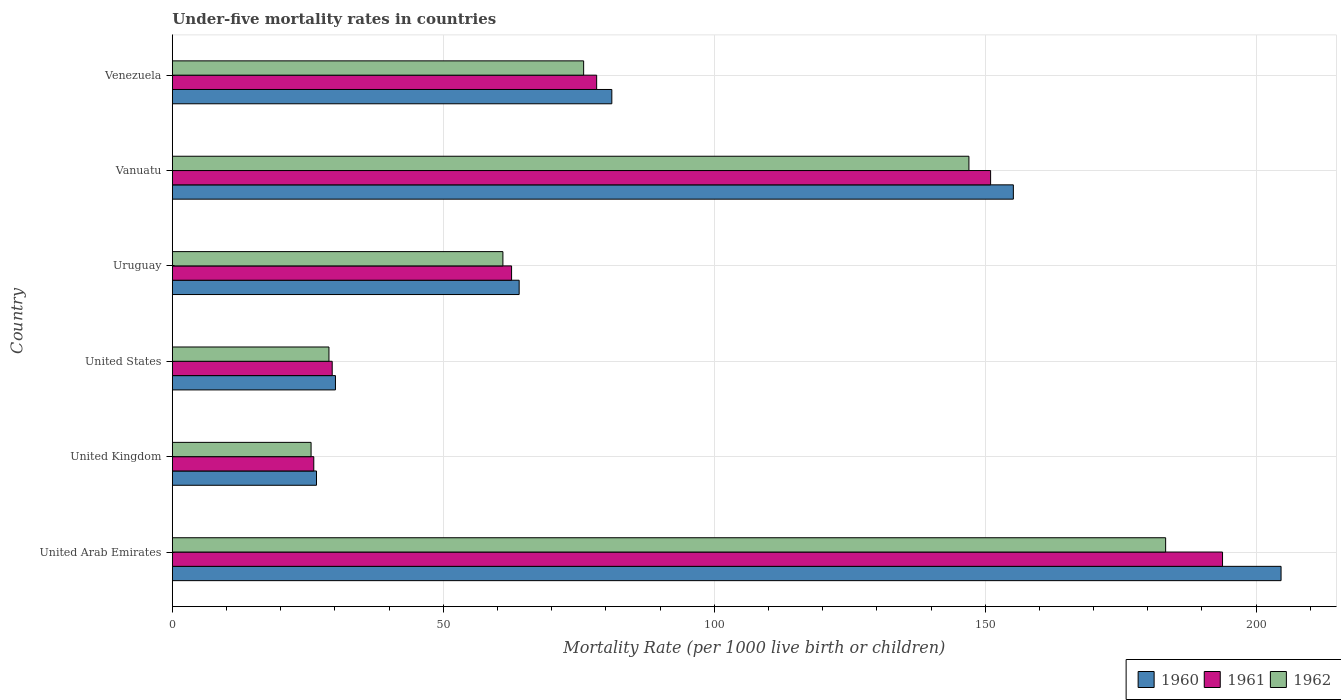How many different coloured bars are there?
Your answer should be very brief. 3. How many groups of bars are there?
Your answer should be very brief. 6. Are the number of bars per tick equal to the number of legend labels?
Ensure brevity in your answer.  Yes. In how many cases, is the number of bars for a given country not equal to the number of legend labels?
Give a very brief answer. 0. What is the under-five mortality rate in 1962 in Vanuatu?
Your answer should be compact. 147. Across all countries, what is the maximum under-five mortality rate in 1960?
Offer a terse response. 204.6. Across all countries, what is the minimum under-five mortality rate in 1960?
Make the answer very short. 26.6. In which country was the under-five mortality rate in 1960 maximum?
Ensure brevity in your answer.  United Arab Emirates. What is the total under-five mortality rate in 1960 in the graph?
Ensure brevity in your answer.  561.6. What is the difference between the under-five mortality rate in 1962 in United States and that in Uruguay?
Provide a succinct answer. -32.1. What is the difference between the under-five mortality rate in 1961 in Uruguay and the under-five mortality rate in 1962 in Vanuatu?
Your answer should be very brief. -84.4. What is the average under-five mortality rate in 1962 per country?
Offer a terse response. 86.95. What is the difference between the under-five mortality rate in 1961 and under-five mortality rate in 1962 in Venezuela?
Your response must be concise. 2.4. In how many countries, is the under-five mortality rate in 1961 greater than 70 ?
Your answer should be compact. 3. What is the ratio of the under-five mortality rate in 1961 in United Kingdom to that in United States?
Make the answer very short. 0.88. What is the difference between the highest and the second highest under-five mortality rate in 1961?
Keep it short and to the point. 42.8. What is the difference between the highest and the lowest under-five mortality rate in 1962?
Provide a succinct answer. 157.7. What does the 1st bar from the top in Vanuatu represents?
Your response must be concise. 1962. What does the 2nd bar from the bottom in United Kingdom represents?
Keep it short and to the point. 1961. How many bars are there?
Your answer should be compact. 18. Does the graph contain grids?
Offer a terse response. Yes. How are the legend labels stacked?
Your response must be concise. Horizontal. What is the title of the graph?
Make the answer very short. Under-five mortality rates in countries. Does "2004" appear as one of the legend labels in the graph?
Provide a succinct answer. No. What is the label or title of the X-axis?
Your answer should be compact. Mortality Rate (per 1000 live birth or children). What is the label or title of the Y-axis?
Make the answer very short. Country. What is the Mortality Rate (per 1000 live birth or children) in 1960 in United Arab Emirates?
Your response must be concise. 204.6. What is the Mortality Rate (per 1000 live birth or children) in 1961 in United Arab Emirates?
Make the answer very short. 193.8. What is the Mortality Rate (per 1000 live birth or children) in 1962 in United Arab Emirates?
Make the answer very short. 183.3. What is the Mortality Rate (per 1000 live birth or children) of 1960 in United Kingdom?
Your answer should be compact. 26.6. What is the Mortality Rate (per 1000 live birth or children) in 1961 in United Kingdom?
Ensure brevity in your answer.  26.1. What is the Mortality Rate (per 1000 live birth or children) in 1962 in United Kingdom?
Provide a succinct answer. 25.6. What is the Mortality Rate (per 1000 live birth or children) in 1960 in United States?
Ensure brevity in your answer.  30.1. What is the Mortality Rate (per 1000 live birth or children) in 1961 in United States?
Give a very brief answer. 29.5. What is the Mortality Rate (per 1000 live birth or children) of 1962 in United States?
Make the answer very short. 28.9. What is the Mortality Rate (per 1000 live birth or children) of 1960 in Uruguay?
Provide a short and direct response. 64. What is the Mortality Rate (per 1000 live birth or children) in 1961 in Uruguay?
Keep it short and to the point. 62.6. What is the Mortality Rate (per 1000 live birth or children) in 1962 in Uruguay?
Make the answer very short. 61. What is the Mortality Rate (per 1000 live birth or children) of 1960 in Vanuatu?
Offer a terse response. 155.2. What is the Mortality Rate (per 1000 live birth or children) of 1961 in Vanuatu?
Give a very brief answer. 151. What is the Mortality Rate (per 1000 live birth or children) in 1962 in Vanuatu?
Your answer should be very brief. 147. What is the Mortality Rate (per 1000 live birth or children) of 1960 in Venezuela?
Offer a terse response. 81.1. What is the Mortality Rate (per 1000 live birth or children) of 1961 in Venezuela?
Ensure brevity in your answer.  78.3. What is the Mortality Rate (per 1000 live birth or children) in 1962 in Venezuela?
Ensure brevity in your answer.  75.9. Across all countries, what is the maximum Mortality Rate (per 1000 live birth or children) in 1960?
Your answer should be very brief. 204.6. Across all countries, what is the maximum Mortality Rate (per 1000 live birth or children) in 1961?
Ensure brevity in your answer.  193.8. Across all countries, what is the maximum Mortality Rate (per 1000 live birth or children) of 1962?
Offer a terse response. 183.3. Across all countries, what is the minimum Mortality Rate (per 1000 live birth or children) in 1960?
Make the answer very short. 26.6. Across all countries, what is the minimum Mortality Rate (per 1000 live birth or children) in 1961?
Offer a very short reply. 26.1. Across all countries, what is the minimum Mortality Rate (per 1000 live birth or children) of 1962?
Provide a succinct answer. 25.6. What is the total Mortality Rate (per 1000 live birth or children) of 1960 in the graph?
Offer a terse response. 561.6. What is the total Mortality Rate (per 1000 live birth or children) in 1961 in the graph?
Your answer should be compact. 541.3. What is the total Mortality Rate (per 1000 live birth or children) of 1962 in the graph?
Offer a terse response. 521.7. What is the difference between the Mortality Rate (per 1000 live birth or children) of 1960 in United Arab Emirates and that in United Kingdom?
Offer a terse response. 178. What is the difference between the Mortality Rate (per 1000 live birth or children) of 1961 in United Arab Emirates and that in United Kingdom?
Give a very brief answer. 167.7. What is the difference between the Mortality Rate (per 1000 live birth or children) of 1962 in United Arab Emirates and that in United Kingdom?
Provide a short and direct response. 157.7. What is the difference between the Mortality Rate (per 1000 live birth or children) of 1960 in United Arab Emirates and that in United States?
Give a very brief answer. 174.5. What is the difference between the Mortality Rate (per 1000 live birth or children) of 1961 in United Arab Emirates and that in United States?
Ensure brevity in your answer.  164.3. What is the difference between the Mortality Rate (per 1000 live birth or children) in 1962 in United Arab Emirates and that in United States?
Offer a terse response. 154.4. What is the difference between the Mortality Rate (per 1000 live birth or children) in 1960 in United Arab Emirates and that in Uruguay?
Provide a succinct answer. 140.6. What is the difference between the Mortality Rate (per 1000 live birth or children) of 1961 in United Arab Emirates and that in Uruguay?
Your answer should be compact. 131.2. What is the difference between the Mortality Rate (per 1000 live birth or children) in 1962 in United Arab Emirates and that in Uruguay?
Your answer should be very brief. 122.3. What is the difference between the Mortality Rate (per 1000 live birth or children) of 1960 in United Arab Emirates and that in Vanuatu?
Offer a terse response. 49.4. What is the difference between the Mortality Rate (per 1000 live birth or children) in 1961 in United Arab Emirates and that in Vanuatu?
Provide a short and direct response. 42.8. What is the difference between the Mortality Rate (per 1000 live birth or children) of 1962 in United Arab Emirates and that in Vanuatu?
Offer a very short reply. 36.3. What is the difference between the Mortality Rate (per 1000 live birth or children) of 1960 in United Arab Emirates and that in Venezuela?
Make the answer very short. 123.5. What is the difference between the Mortality Rate (per 1000 live birth or children) in 1961 in United Arab Emirates and that in Venezuela?
Your answer should be compact. 115.5. What is the difference between the Mortality Rate (per 1000 live birth or children) of 1962 in United Arab Emirates and that in Venezuela?
Provide a succinct answer. 107.4. What is the difference between the Mortality Rate (per 1000 live birth or children) of 1960 in United Kingdom and that in United States?
Your answer should be very brief. -3.5. What is the difference between the Mortality Rate (per 1000 live birth or children) of 1962 in United Kingdom and that in United States?
Offer a terse response. -3.3. What is the difference between the Mortality Rate (per 1000 live birth or children) of 1960 in United Kingdom and that in Uruguay?
Provide a succinct answer. -37.4. What is the difference between the Mortality Rate (per 1000 live birth or children) in 1961 in United Kingdom and that in Uruguay?
Make the answer very short. -36.5. What is the difference between the Mortality Rate (per 1000 live birth or children) in 1962 in United Kingdom and that in Uruguay?
Your answer should be very brief. -35.4. What is the difference between the Mortality Rate (per 1000 live birth or children) of 1960 in United Kingdom and that in Vanuatu?
Keep it short and to the point. -128.6. What is the difference between the Mortality Rate (per 1000 live birth or children) of 1961 in United Kingdom and that in Vanuatu?
Your answer should be very brief. -124.9. What is the difference between the Mortality Rate (per 1000 live birth or children) in 1962 in United Kingdom and that in Vanuatu?
Your answer should be compact. -121.4. What is the difference between the Mortality Rate (per 1000 live birth or children) of 1960 in United Kingdom and that in Venezuela?
Offer a very short reply. -54.5. What is the difference between the Mortality Rate (per 1000 live birth or children) of 1961 in United Kingdom and that in Venezuela?
Ensure brevity in your answer.  -52.2. What is the difference between the Mortality Rate (per 1000 live birth or children) of 1962 in United Kingdom and that in Venezuela?
Make the answer very short. -50.3. What is the difference between the Mortality Rate (per 1000 live birth or children) of 1960 in United States and that in Uruguay?
Ensure brevity in your answer.  -33.9. What is the difference between the Mortality Rate (per 1000 live birth or children) of 1961 in United States and that in Uruguay?
Make the answer very short. -33.1. What is the difference between the Mortality Rate (per 1000 live birth or children) of 1962 in United States and that in Uruguay?
Provide a succinct answer. -32.1. What is the difference between the Mortality Rate (per 1000 live birth or children) of 1960 in United States and that in Vanuatu?
Offer a very short reply. -125.1. What is the difference between the Mortality Rate (per 1000 live birth or children) of 1961 in United States and that in Vanuatu?
Offer a very short reply. -121.5. What is the difference between the Mortality Rate (per 1000 live birth or children) of 1962 in United States and that in Vanuatu?
Your answer should be compact. -118.1. What is the difference between the Mortality Rate (per 1000 live birth or children) in 1960 in United States and that in Venezuela?
Offer a terse response. -51. What is the difference between the Mortality Rate (per 1000 live birth or children) of 1961 in United States and that in Venezuela?
Give a very brief answer. -48.8. What is the difference between the Mortality Rate (per 1000 live birth or children) of 1962 in United States and that in Venezuela?
Provide a succinct answer. -47. What is the difference between the Mortality Rate (per 1000 live birth or children) in 1960 in Uruguay and that in Vanuatu?
Make the answer very short. -91.2. What is the difference between the Mortality Rate (per 1000 live birth or children) in 1961 in Uruguay and that in Vanuatu?
Make the answer very short. -88.4. What is the difference between the Mortality Rate (per 1000 live birth or children) of 1962 in Uruguay and that in Vanuatu?
Ensure brevity in your answer.  -86. What is the difference between the Mortality Rate (per 1000 live birth or children) in 1960 in Uruguay and that in Venezuela?
Your response must be concise. -17.1. What is the difference between the Mortality Rate (per 1000 live birth or children) of 1961 in Uruguay and that in Venezuela?
Your answer should be very brief. -15.7. What is the difference between the Mortality Rate (per 1000 live birth or children) in 1962 in Uruguay and that in Venezuela?
Provide a succinct answer. -14.9. What is the difference between the Mortality Rate (per 1000 live birth or children) in 1960 in Vanuatu and that in Venezuela?
Your answer should be compact. 74.1. What is the difference between the Mortality Rate (per 1000 live birth or children) of 1961 in Vanuatu and that in Venezuela?
Keep it short and to the point. 72.7. What is the difference between the Mortality Rate (per 1000 live birth or children) of 1962 in Vanuatu and that in Venezuela?
Provide a succinct answer. 71.1. What is the difference between the Mortality Rate (per 1000 live birth or children) of 1960 in United Arab Emirates and the Mortality Rate (per 1000 live birth or children) of 1961 in United Kingdom?
Your response must be concise. 178.5. What is the difference between the Mortality Rate (per 1000 live birth or children) in 1960 in United Arab Emirates and the Mortality Rate (per 1000 live birth or children) in 1962 in United Kingdom?
Provide a short and direct response. 179. What is the difference between the Mortality Rate (per 1000 live birth or children) in 1961 in United Arab Emirates and the Mortality Rate (per 1000 live birth or children) in 1962 in United Kingdom?
Provide a short and direct response. 168.2. What is the difference between the Mortality Rate (per 1000 live birth or children) in 1960 in United Arab Emirates and the Mortality Rate (per 1000 live birth or children) in 1961 in United States?
Offer a terse response. 175.1. What is the difference between the Mortality Rate (per 1000 live birth or children) of 1960 in United Arab Emirates and the Mortality Rate (per 1000 live birth or children) of 1962 in United States?
Offer a terse response. 175.7. What is the difference between the Mortality Rate (per 1000 live birth or children) in 1961 in United Arab Emirates and the Mortality Rate (per 1000 live birth or children) in 1962 in United States?
Offer a very short reply. 164.9. What is the difference between the Mortality Rate (per 1000 live birth or children) in 1960 in United Arab Emirates and the Mortality Rate (per 1000 live birth or children) in 1961 in Uruguay?
Offer a terse response. 142. What is the difference between the Mortality Rate (per 1000 live birth or children) in 1960 in United Arab Emirates and the Mortality Rate (per 1000 live birth or children) in 1962 in Uruguay?
Offer a very short reply. 143.6. What is the difference between the Mortality Rate (per 1000 live birth or children) of 1961 in United Arab Emirates and the Mortality Rate (per 1000 live birth or children) of 1962 in Uruguay?
Give a very brief answer. 132.8. What is the difference between the Mortality Rate (per 1000 live birth or children) of 1960 in United Arab Emirates and the Mortality Rate (per 1000 live birth or children) of 1961 in Vanuatu?
Your response must be concise. 53.6. What is the difference between the Mortality Rate (per 1000 live birth or children) in 1960 in United Arab Emirates and the Mortality Rate (per 1000 live birth or children) in 1962 in Vanuatu?
Offer a terse response. 57.6. What is the difference between the Mortality Rate (per 1000 live birth or children) in 1961 in United Arab Emirates and the Mortality Rate (per 1000 live birth or children) in 1962 in Vanuatu?
Your answer should be compact. 46.8. What is the difference between the Mortality Rate (per 1000 live birth or children) of 1960 in United Arab Emirates and the Mortality Rate (per 1000 live birth or children) of 1961 in Venezuela?
Give a very brief answer. 126.3. What is the difference between the Mortality Rate (per 1000 live birth or children) in 1960 in United Arab Emirates and the Mortality Rate (per 1000 live birth or children) in 1962 in Venezuela?
Offer a terse response. 128.7. What is the difference between the Mortality Rate (per 1000 live birth or children) of 1961 in United Arab Emirates and the Mortality Rate (per 1000 live birth or children) of 1962 in Venezuela?
Ensure brevity in your answer.  117.9. What is the difference between the Mortality Rate (per 1000 live birth or children) of 1960 in United Kingdom and the Mortality Rate (per 1000 live birth or children) of 1961 in United States?
Your response must be concise. -2.9. What is the difference between the Mortality Rate (per 1000 live birth or children) in 1960 in United Kingdom and the Mortality Rate (per 1000 live birth or children) in 1961 in Uruguay?
Provide a succinct answer. -36. What is the difference between the Mortality Rate (per 1000 live birth or children) in 1960 in United Kingdom and the Mortality Rate (per 1000 live birth or children) in 1962 in Uruguay?
Make the answer very short. -34.4. What is the difference between the Mortality Rate (per 1000 live birth or children) of 1961 in United Kingdom and the Mortality Rate (per 1000 live birth or children) of 1962 in Uruguay?
Keep it short and to the point. -34.9. What is the difference between the Mortality Rate (per 1000 live birth or children) of 1960 in United Kingdom and the Mortality Rate (per 1000 live birth or children) of 1961 in Vanuatu?
Give a very brief answer. -124.4. What is the difference between the Mortality Rate (per 1000 live birth or children) of 1960 in United Kingdom and the Mortality Rate (per 1000 live birth or children) of 1962 in Vanuatu?
Your answer should be compact. -120.4. What is the difference between the Mortality Rate (per 1000 live birth or children) in 1961 in United Kingdom and the Mortality Rate (per 1000 live birth or children) in 1962 in Vanuatu?
Make the answer very short. -120.9. What is the difference between the Mortality Rate (per 1000 live birth or children) in 1960 in United Kingdom and the Mortality Rate (per 1000 live birth or children) in 1961 in Venezuela?
Your response must be concise. -51.7. What is the difference between the Mortality Rate (per 1000 live birth or children) of 1960 in United Kingdom and the Mortality Rate (per 1000 live birth or children) of 1962 in Venezuela?
Keep it short and to the point. -49.3. What is the difference between the Mortality Rate (per 1000 live birth or children) in 1961 in United Kingdom and the Mortality Rate (per 1000 live birth or children) in 1962 in Venezuela?
Ensure brevity in your answer.  -49.8. What is the difference between the Mortality Rate (per 1000 live birth or children) in 1960 in United States and the Mortality Rate (per 1000 live birth or children) in 1961 in Uruguay?
Your response must be concise. -32.5. What is the difference between the Mortality Rate (per 1000 live birth or children) in 1960 in United States and the Mortality Rate (per 1000 live birth or children) in 1962 in Uruguay?
Ensure brevity in your answer.  -30.9. What is the difference between the Mortality Rate (per 1000 live birth or children) in 1961 in United States and the Mortality Rate (per 1000 live birth or children) in 1962 in Uruguay?
Your response must be concise. -31.5. What is the difference between the Mortality Rate (per 1000 live birth or children) of 1960 in United States and the Mortality Rate (per 1000 live birth or children) of 1961 in Vanuatu?
Offer a terse response. -120.9. What is the difference between the Mortality Rate (per 1000 live birth or children) in 1960 in United States and the Mortality Rate (per 1000 live birth or children) in 1962 in Vanuatu?
Make the answer very short. -116.9. What is the difference between the Mortality Rate (per 1000 live birth or children) of 1961 in United States and the Mortality Rate (per 1000 live birth or children) of 1962 in Vanuatu?
Provide a succinct answer. -117.5. What is the difference between the Mortality Rate (per 1000 live birth or children) of 1960 in United States and the Mortality Rate (per 1000 live birth or children) of 1961 in Venezuela?
Give a very brief answer. -48.2. What is the difference between the Mortality Rate (per 1000 live birth or children) of 1960 in United States and the Mortality Rate (per 1000 live birth or children) of 1962 in Venezuela?
Ensure brevity in your answer.  -45.8. What is the difference between the Mortality Rate (per 1000 live birth or children) of 1961 in United States and the Mortality Rate (per 1000 live birth or children) of 1962 in Venezuela?
Provide a short and direct response. -46.4. What is the difference between the Mortality Rate (per 1000 live birth or children) in 1960 in Uruguay and the Mortality Rate (per 1000 live birth or children) in 1961 in Vanuatu?
Provide a short and direct response. -87. What is the difference between the Mortality Rate (per 1000 live birth or children) in 1960 in Uruguay and the Mortality Rate (per 1000 live birth or children) in 1962 in Vanuatu?
Offer a very short reply. -83. What is the difference between the Mortality Rate (per 1000 live birth or children) of 1961 in Uruguay and the Mortality Rate (per 1000 live birth or children) of 1962 in Vanuatu?
Offer a terse response. -84.4. What is the difference between the Mortality Rate (per 1000 live birth or children) in 1960 in Uruguay and the Mortality Rate (per 1000 live birth or children) in 1961 in Venezuela?
Your answer should be compact. -14.3. What is the difference between the Mortality Rate (per 1000 live birth or children) in 1961 in Uruguay and the Mortality Rate (per 1000 live birth or children) in 1962 in Venezuela?
Your response must be concise. -13.3. What is the difference between the Mortality Rate (per 1000 live birth or children) of 1960 in Vanuatu and the Mortality Rate (per 1000 live birth or children) of 1961 in Venezuela?
Your answer should be very brief. 76.9. What is the difference between the Mortality Rate (per 1000 live birth or children) of 1960 in Vanuatu and the Mortality Rate (per 1000 live birth or children) of 1962 in Venezuela?
Your answer should be compact. 79.3. What is the difference between the Mortality Rate (per 1000 live birth or children) of 1961 in Vanuatu and the Mortality Rate (per 1000 live birth or children) of 1962 in Venezuela?
Provide a succinct answer. 75.1. What is the average Mortality Rate (per 1000 live birth or children) in 1960 per country?
Offer a very short reply. 93.6. What is the average Mortality Rate (per 1000 live birth or children) of 1961 per country?
Provide a short and direct response. 90.22. What is the average Mortality Rate (per 1000 live birth or children) of 1962 per country?
Make the answer very short. 86.95. What is the difference between the Mortality Rate (per 1000 live birth or children) of 1960 and Mortality Rate (per 1000 live birth or children) of 1961 in United Arab Emirates?
Make the answer very short. 10.8. What is the difference between the Mortality Rate (per 1000 live birth or children) of 1960 and Mortality Rate (per 1000 live birth or children) of 1962 in United Arab Emirates?
Give a very brief answer. 21.3. What is the difference between the Mortality Rate (per 1000 live birth or children) in 1961 and Mortality Rate (per 1000 live birth or children) in 1962 in United Arab Emirates?
Provide a succinct answer. 10.5. What is the difference between the Mortality Rate (per 1000 live birth or children) of 1960 and Mortality Rate (per 1000 live birth or children) of 1961 in United Kingdom?
Provide a short and direct response. 0.5. What is the difference between the Mortality Rate (per 1000 live birth or children) of 1961 and Mortality Rate (per 1000 live birth or children) of 1962 in United Kingdom?
Keep it short and to the point. 0.5. What is the difference between the Mortality Rate (per 1000 live birth or children) of 1960 and Mortality Rate (per 1000 live birth or children) of 1962 in United States?
Ensure brevity in your answer.  1.2. What is the difference between the Mortality Rate (per 1000 live birth or children) of 1960 and Mortality Rate (per 1000 live birth or children) of 1962 in Vanuatu?
Offer a terse response. 8.2. What is the difference between the Mortality Rate (per 1000 live birth or children) in 1961 and Mortality Rate (per 1000 live birth or children) in 1962 in Vanuatu?
Your answer should be very brief. 4. What is the difference between the Mortality Rate (per 1000 live birth or children) of 1960 and Mortality Rate (per 1000 live birth or children) of 1962 in Venezuela?
Give a very brief answer. 5.2. What is the ratio of the Mortality Rate (per 1000 live birth or children) of 1960 in United Arab Emirates to that in United Kingdom?
Make the answer very short. 7.69. What is the ratio of the Mortality Rate (per 1000 live birth or children) in 1961 in United Arab Emirates to that in United Kingdom?
Your answer should be compact. 7.43. What is the ratio of the Mortality Rate (per 1000 live birth or children) in 1962 in United Arab Emirates to that in United Kingdom?
Provide a short and direct response. 7.16. What is the ratio of the Mortality Rate (per 1000 live birth or children) of 1960 in United Arab Emirates to that in United States?
Your answer should be very brief. 6.8. What is the ratio of the Mortality Rate (per 1000 live birth or children) of 1961 in United Arab Emirates to that in United States?
Ensure brevity in your answer.  6.57. What is the ratio of the Mortality Rate (per 1000 live birth or children) of 1962 in United Arab Emirates to that in United States?
Make the answer very short. 6.34. What is the ratio of the Mortality Rate (per 1000 live birth or children) of 1960 in United Arab Emirates to that in Uruguay?
Give a very brief answer. 3.2. What is the ratio of the Mortality Rate (per 1000 live birth or children) of 1961 in United Arab Emirates to that in Uruguay?
Your response must be concise. 3.1. What is the ratio of the Mortality Rate (per 1000 live birth or children) in 1962 in United Arab Emirates to that in Uruguay?
Give a very brief answer. 3. What is the ratio of the Mortality Rate (per 1000 live birth or children) in 1960 in United Arab Emirates to that in Vanuatu?
Your answer should be compact. 1.32. What is the ratio of the Mortality Rate (per 1000 live birth or children) in 1961 in United Arab Emirates to that in Vanuatu?
Give a very brief answer. 1.28. What is the ratio of the Mortality Rate (per 1000 live birth or children) in 1962 in United Arab Emirates to that in Vanuatu?
Your answer should be very brief. 1.25. What is the ratio of the Mortality Rate (per 1000 live birth or children) in 1960 in United Arab Emirates to that in Venezuela?
Your response must be concise. 2.52. What is the ratio of the Mortality Rate (per 1000 live birth or children) of 1961 in United Arab Emirates to that in Venezuela?
Offer a very short reply. 2.48. What is the ratio of the Mortality Rate (per 1000 live birth or children) in 1962 in United Arab Emirates to that in Venezuela?
Offer a terse response. 2.42. What is the ratio of the Mortality Rate (per 1000 live birth or children) of 1960 in United Kingdom to that in United States?
Your response must be concise. 0.88. What is the ratio of the Mortality Rate (per 1000 live birth or children) of 1961 in United Kingdom to that in United States?
Keep it short and to the point. 0.88. What is the ratio of the Mortality Rate (per 1000 live birth or children) in 1962 in United Kingdom to that in United States?
Ensure brevity in your answer.  0.89. What is the ratio of the Mortality Rate (per 1000 live birth or children) of 1960 in United Kingdom to that in Uruguay?
Make the answer very short. 0.42. What is the ratio of the Mortality Rate (per 1000 live birth or children) in 1961 in United Kingdom to that in Uruguay?
Ensure brevity in your answer.  0.42. What is the ratio of the Mortality Rate (per 1000 live birth or children) of 1962 in United Kingdom to that in Uruguay?
Offer a very short reply. 0.42. What is the ratio of the Mortality Rate (per 1000 live birth or children) of 1960 in United Kingdom to that in Vanuatu?
Offer a very short reply. 0.17. What is the ratio of the Mortality Rate (per 1000 live birth or children) of 1961 in United Kingdom to that in Vanuatu?
Make the answer very short. 0.17. What is the ratio of the Mortality Rate (per 1000 live birth or children) in 1962 in United Kingdom to that in Vanuatu?
Provide a succinct answer. 0.17. What is the ratio of the Mortality Rate (per 1000 live birth or children) of 1960 in United Kingdom to that in Venezuela?
Offer a very short reply. 0.33. What is the ratio of the Mortality Rate (per 1000 live birth or children) of 1961 in United Kingdom to that in Venezuela?
Give a very brief answer. 0.33. What is the ratio of the Mortality Rate (per 1000 live birth or children) of 1962 in United Kingdom to that in Venezuela?
Your response must be concise. 0.34. What is the ratio of the Mortality Rate (per 1000 live birth or children) in 1960 in United States to that in Uruguay?
Your answer should be very brief. 0.47. What is the ratio of the Mortality Rate (per 1000 live birth or children) of 1961 in United States to that in Uruguay?
Keep it short and to the point. 0.47. What is the ratio of the Mortality Rate (per 1000 live birth or children) of 1962 in United States to that in Uruguay?
Offer a very short reply. 0.47. What is the ratio of the Mortality Rate (per 1000 live birth or children) of 1960 in United States to that in Vanuatu?
Give a very brief answer. 0.19. What is the ratio of the Mortality Rate (per 1000 live birth or children) in 1961 in United States to that in Vanuatu?
Give a very brief answer. 0.2. What is the ratio of the Mortality Rate (per 1000 live birth or children) of 1962 in United States to that in Vanuatu?
Your response must be concise. 0.2. What is the ratio of the Mortality Rate (per 1000 live birth or children) in 1960 in United States to that in Venezuela?
Ensure brevity in your answer.  0.37. What is the ratio of the Mortality Rate (per 1000 live birth or children) in 1961 in United States to that in Venezuela?
Your answer should be compact. 0.38. What is the ratio of the Mortality Rate (per 1000 live birth or children) of 1962 in United States to that in Venezuela?
Offer a very short reply. 0.38. What is the ratio of the Mortality Rate (per 1000 live birth or children) of 1960 in Uruguay to that in Vanuatu?
Your answer should be very brief. 0.41. What is the ratio of the Mortality Rate (per 1000 live birth or children) in 1961 in Uruguay to that in Vanuatu?
Ensure brevity in your answer.  0.41. What is the ratio of the Mortality Rate (per 1000 live birth or children) in 1962 in Uruguay to that in Vanuatu?
Provide a short and direct response. 0.41. What is the ratio of the Mortality Rate (per 1000 live birth or children) of 1960 in Uruguay to that in Venezuela?
Offer a terse response. 0.79. What is the ratio of the Mortality Rate (per 1000 live birth or children) in 1961 in Uruguay to that in Venezuela?
Offer a terse response. 0.8. What is the ratio of the Mortality Rate (per 1000 live birth or children) of 1962 in Uruguay to that in Venezuela?
Your answer should be very brief. 0.8. What is the ratio of the Mortality Rate (per 1000 live birth or children) of 1960 in Vanuatu to that in Venezuela?
Give a very brief answer. 1.91. What is the ratio of the Mortality Rate (per 1000 live birth or children) of 1961 in Vanuatu to that in Venezuela?
Offer a very short reply. 1.93. What is the ratio of the Mortality Rate (per 1000 live birth or children) of 1962 in Vanuatu to that in Venezuela?
Make the answer very short. 1.94. What is the difference between the highest and the second highest Mortality Rate (per 1000 live birth or children) in 1960?
Offer a terse response. 49.4. What is the difference between the highest and the second highest Mortality Rate (per 1000 live birth or children) in 1961?
Your answer should be very brief. 42.8. What is the difference between the highest and the second highest Mortality Rate (per 1000 live birth or children) in 1962?
Make the answer very short. 36.3. What is the difference between the highest and the lowest Mortality Rate (per 1000 live birth or children) in 1960?
Provide a succinct answer. 178. What is the difference between the highest and the lowest Mortality Rate (per 1000 live birth or children) in 1961?
Make the answer very short. 167.7. What is the difference between the highest and the lowest Mortality Rate (per 1000 live birth or children) of 1962?
Your response must be concise. 157.7. 